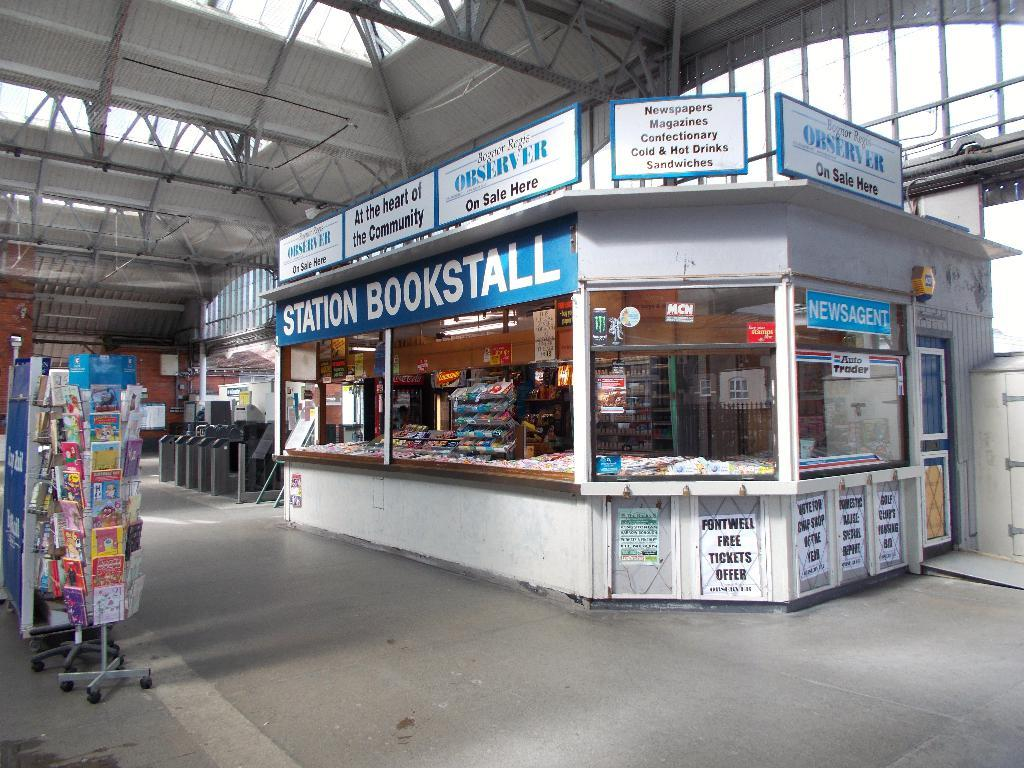Provide a one-sentence caption for the provided image. Bookstall in white and blue inside a station. 